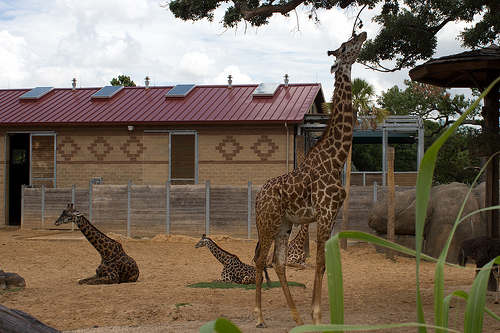Please provide the bounding box coordinate of the region this sentence describes: giraffe sitting on the ground. The coordinates for the bounding box around a giraffe sitting on the ground are [0.1, 0.56, 0.32, 0.75]. 